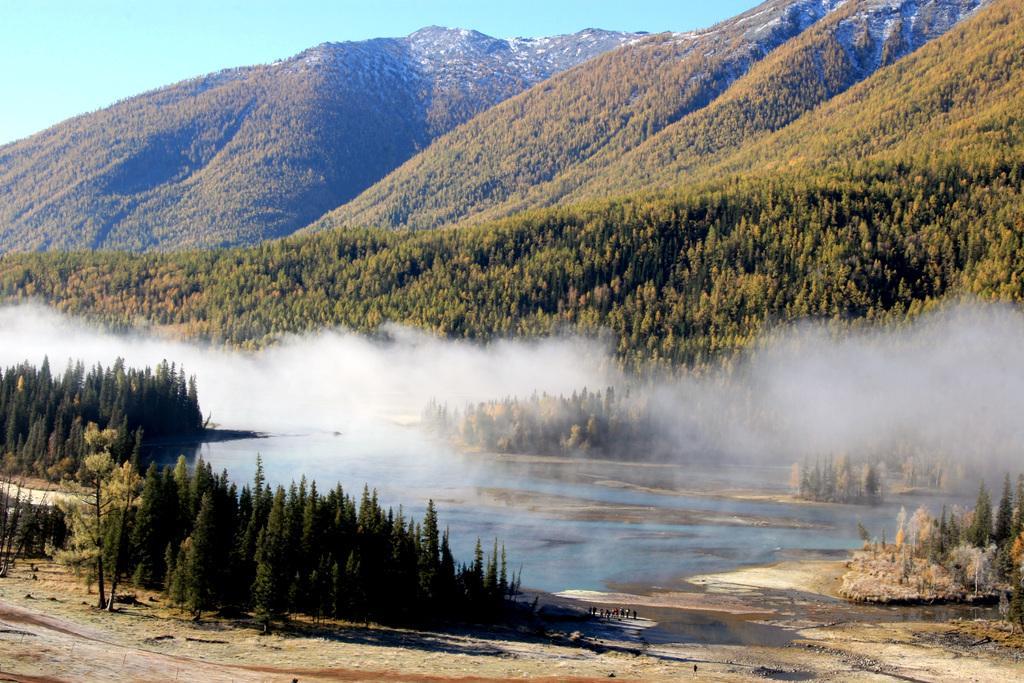Describe this image in one or two sentences. This image is clicked outside. At the bottom, there is ground. In the front, there are plants. In the middle, there are few people standing on the ground. And there is water along with smoke. In the background, there are mountains which are covered with trees and plants. To the top, there is sky. 